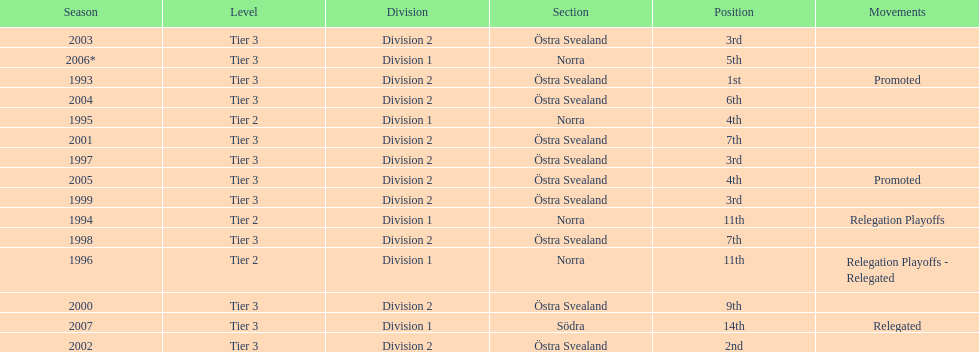What is the only year with the 1st position? 1993. 